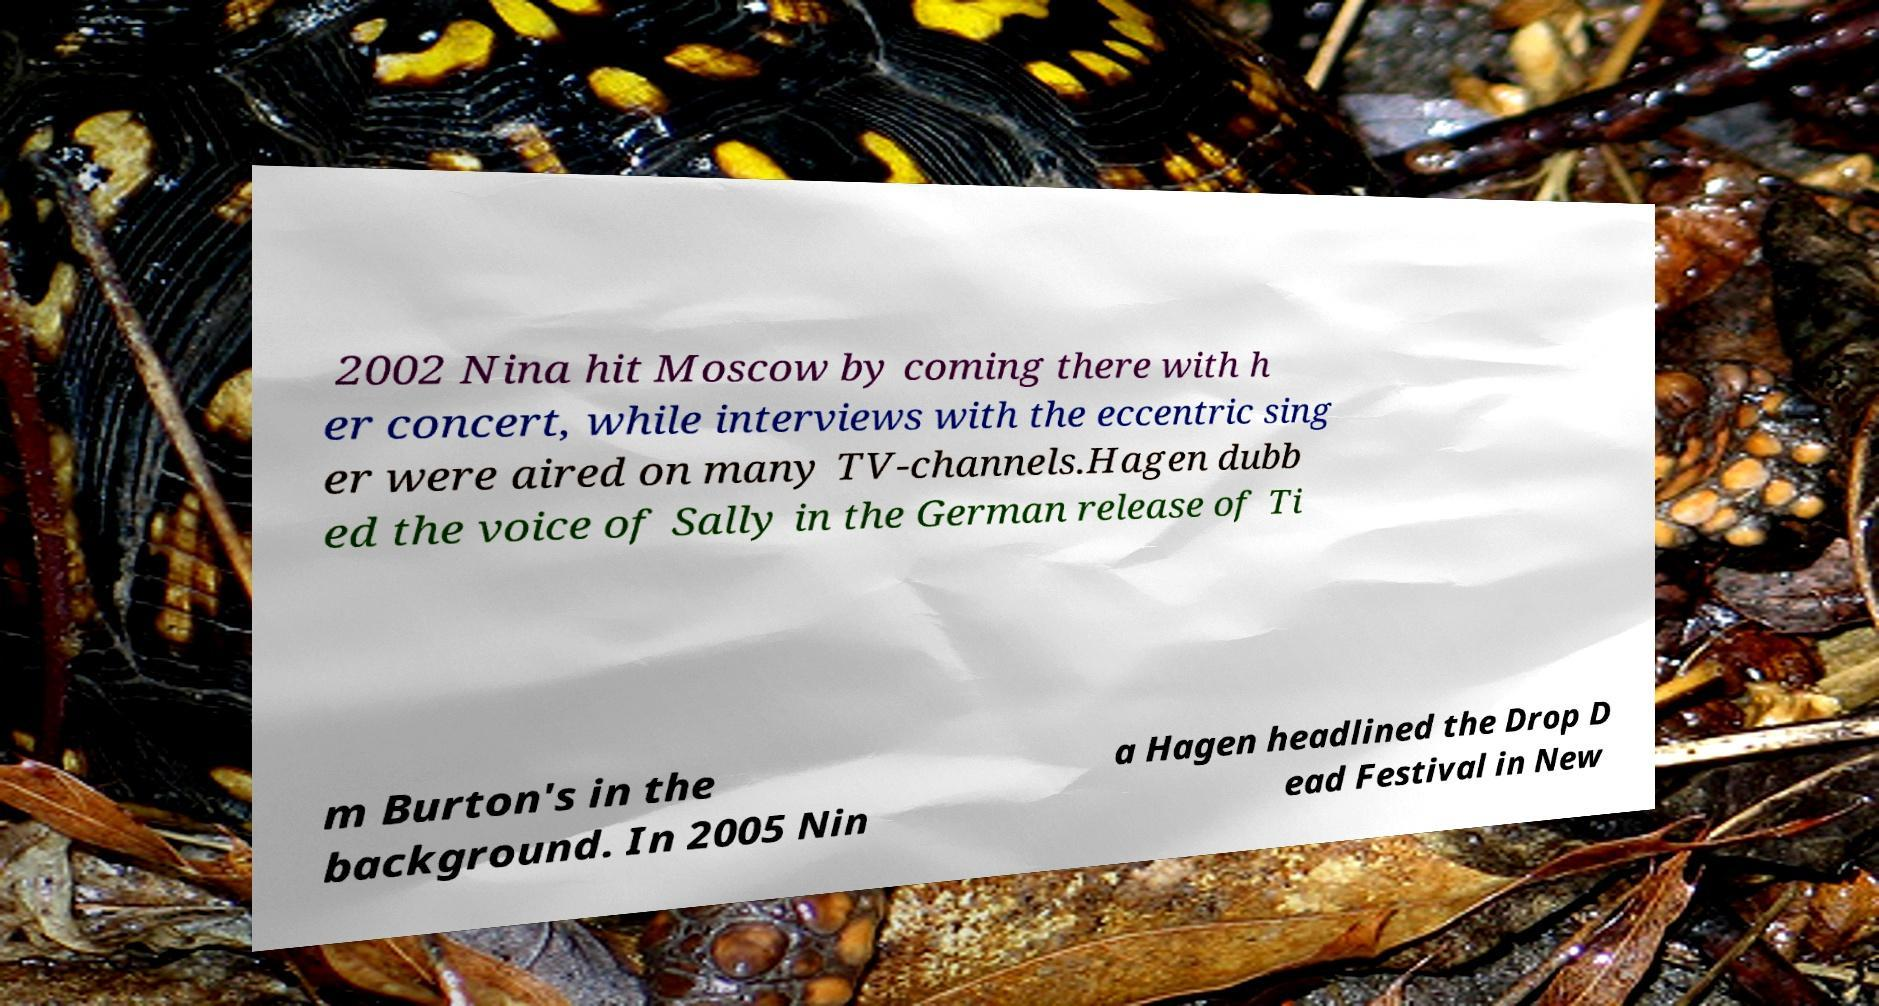Could you extract and type out the text from this image? 2002 Nina hit Moscow by coming there with h er concert, while interviews with the eccentric sing er were aired on many TV-channels.Hagen dubb ed the voice of Sally in the German release of Ti m Burton's in the background. In 2005 Nin a Hagen headlined the Drop D ead Festival in New 